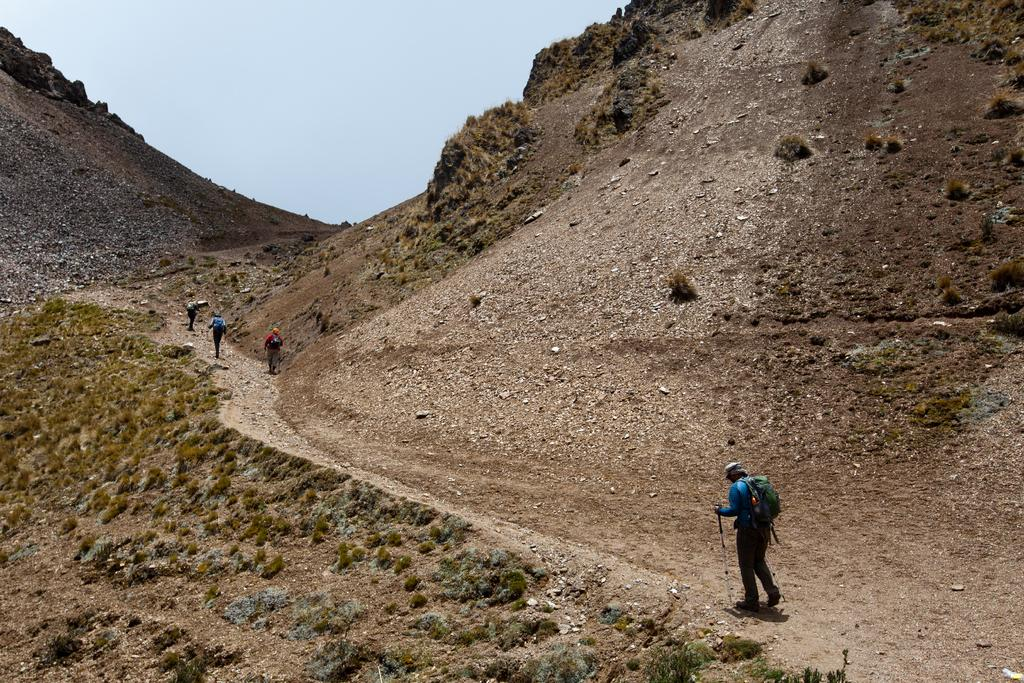What are the people in the image doing? The people in the image are walking. What can be seen in the background of the image? There are hills and the sky visible in the background of the image. What type of bells can be heard ringing in the image? There are no bells present in the image, and therefore no sound can be heard. 